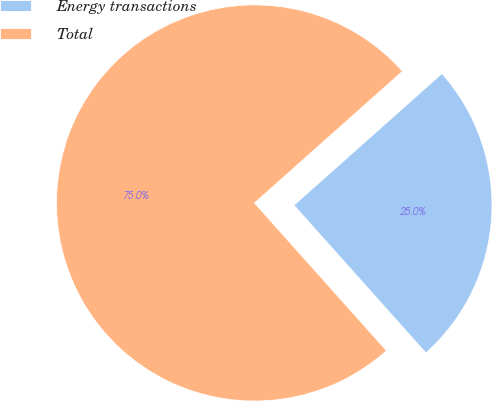Convert chart to OTSL. <chart><loc_0><loc_0><loc_500><loc_500><pie_chart><fcel>Energy transactions<fcel>Total<nl><fcel>24.97%<fcel>75.03%<nl></chart> 